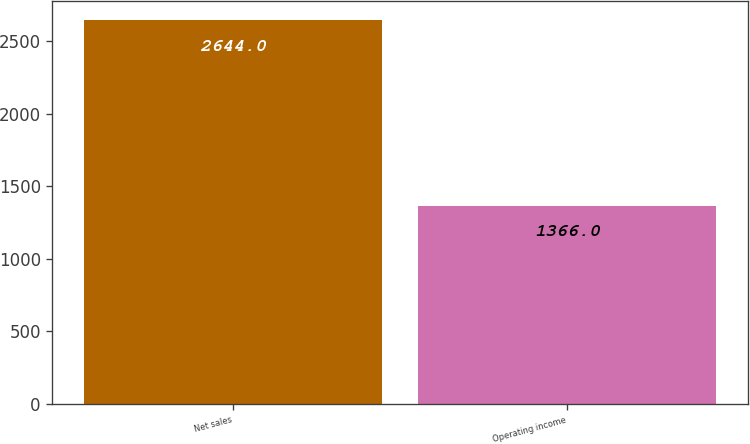Convert chart. <chart><loc_0><loc_0><loc_500><loc_500><bar_chart><fcel>Net sales<fcel>Operating income<nl><fcel>2644<fcel>1366<nl></chart> 